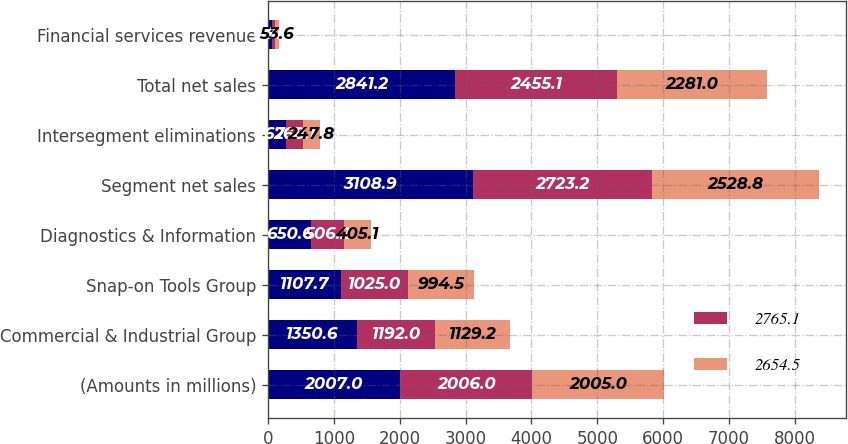Convert chart. <chart><loc_0><loc_0><loc_500><loc_500><stacked_bar_chart><ecel><fcel>(Amounts in millions)<fcel>Commercial & Industrial Group<fcel>Snap-on Tools Group<fcel>Diagnostics & Information<fcel>Segment net sales<fcel>Intersegment eliminations<fcel>Total net sales<fcel>Financial services revenue<nl><fcel>nan<fcel>2007<fcel>1350.6<fcel>1107.7<fcel>650.6<fcel>3108.9<fcel>267.7<fcel>2841.2<fcel>63<nl><fcel>2765.1<fcel>2006<fcel>1192<fcel>1025<fcel>506.2<fcel>2723.2<fcel>268.1<fcel>2455.1<fcel>49<nl><fcel>2654.5<fcel>2005<fcel>1129.2<fcel>994.5<fcel>405.1<fcel>2528.8<fcel>247.8<fcel>2281<fcel>53.6<nl></chart> 